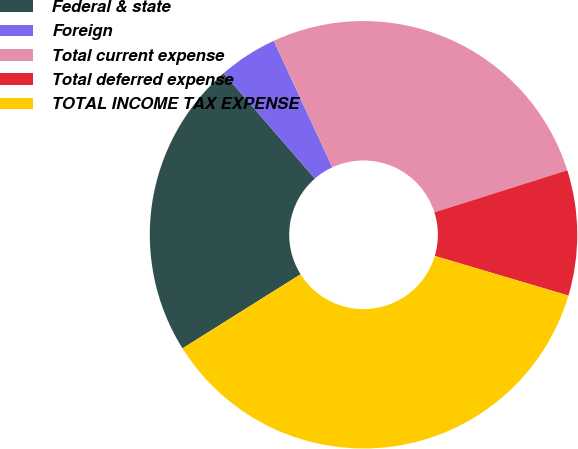Convert chart to OTSL. <chart><loc_0><loc_0><loc_500><loc_500><pie_chart><fcel>Federal & state<fcel>Foreign<fcel>Total current expense<fcel>Total deferred expense<fcel>TOTAL INCOME TAX EXPENSE<nl><fcel>22.56%<fcel>4.46%<fcel>27.02%<fcel>9.47%<fcel>36.49%<nl></chart> 